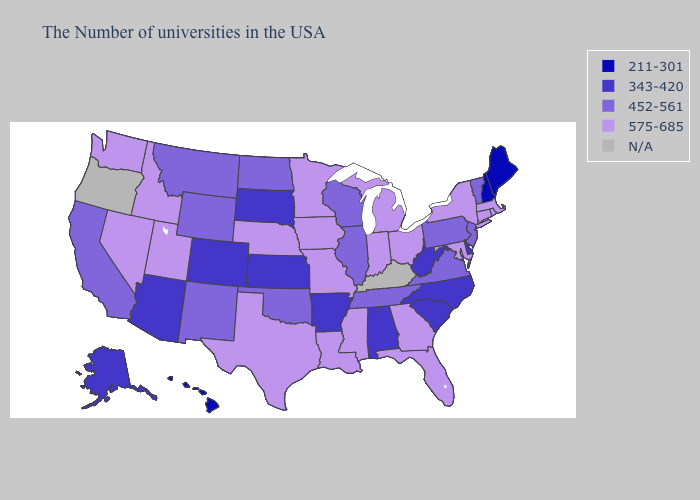Among the states that border Maryland , which have the highest value?
Quick response, please. Pennsylvania, Virginia. Does Ohio have the highest value in the USA?
Quick response, please. Yes. What is the lowest value in the South?
Be succinct. 343-420. What is the value of Wisconsin?
Be succinct. 452-561. Does the map have missing data?
Short answer required. Yes. What is the highest value in the West ?
Quick response, please. 575-685. What is the highest value in states that border Kansas?
Write a very short answer. 575-685. What is the value of Washington?
Short answer required. 575-685. Does the map have missing data?
Keep it brief. Yes. What is the value of Florida?
Answer briefly. 575-685. Does Maine have the highest value in the Northeast?
Give a very brief answer. No. Which states hav the highest value in the South?
Keep it brief. Maryland, Florida, Georgia, Mississippi, Louisiana, Texas. 